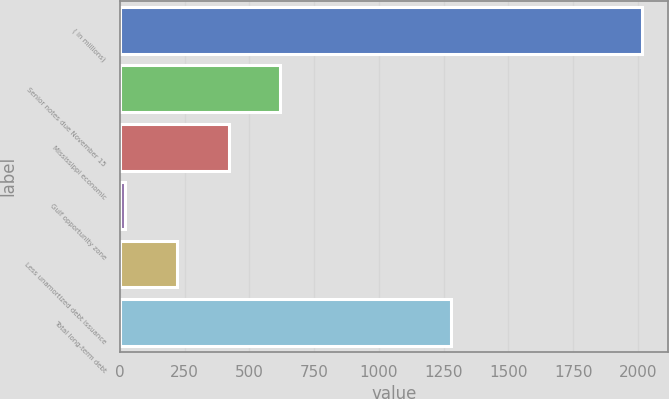Convert chart to OTSL. <chart><loc_0><loc_0><loc_500><loc_500><bar_chart><fcel>( in millions)<fcel>Senior notes due November 15<fcel>Mississippi economic<fcel>Gulf opportunity zone<fcel>Less unamortized debt issuance<fcel>Total long-term debt<nl><fcel>2016<fcel>619.5<fcel>420<fcel>21<fcel>220.5<fcel>1278<nl></chart> 